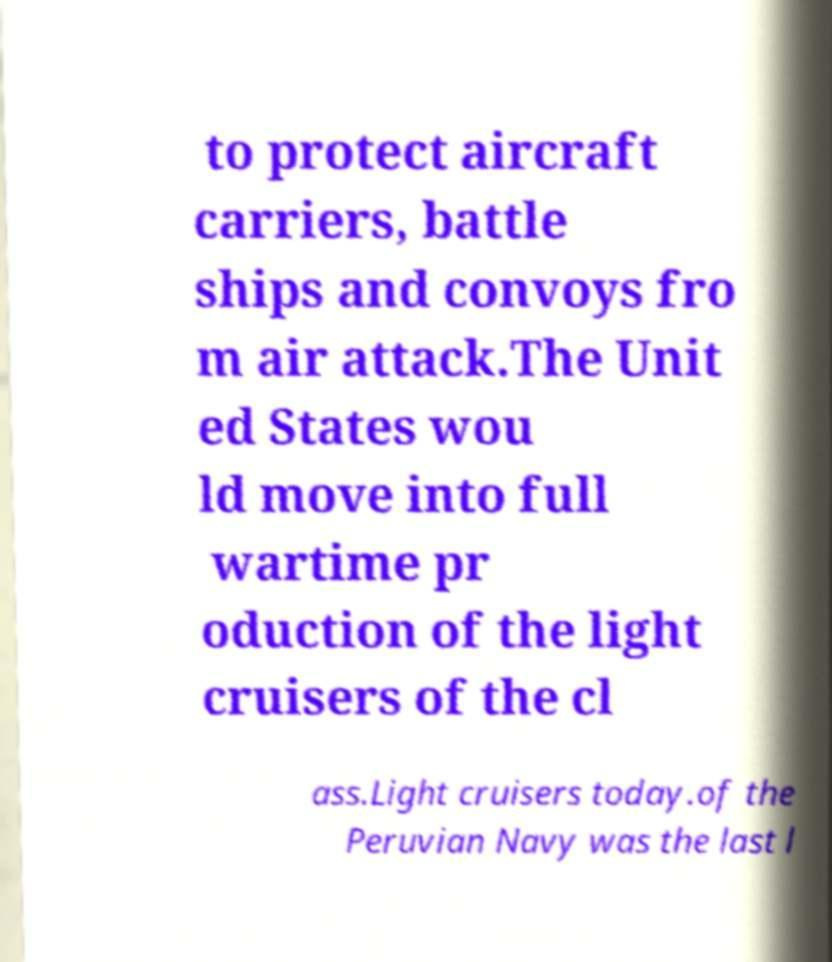Can you accurately transcribe the text from the provided image for me? to protect aircraft carriers, battle ships and convoys fro m air attack.The Unit ed States wou ld move into full wartime pr oduction of the light cruisers of the cl ass.Light cruisers today.of the Peruvian Navy was the last l 